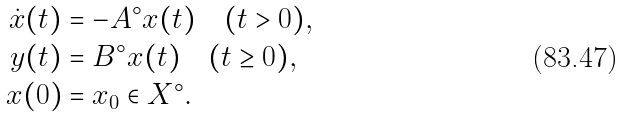<formula> <loc_0><loc_0><loc_500><loc_500>\dot { x } ( t ) & = - A ^ { \circ } x ( t ) \quad ( t > 0 ) , \\ y ( t ) & = B ^ { \circ } x ( t ) \quad ( t \geq 0 ) , \\ x ( 0 ) & = x _ { 0 } \in X ^ { \circ } .</formula> 